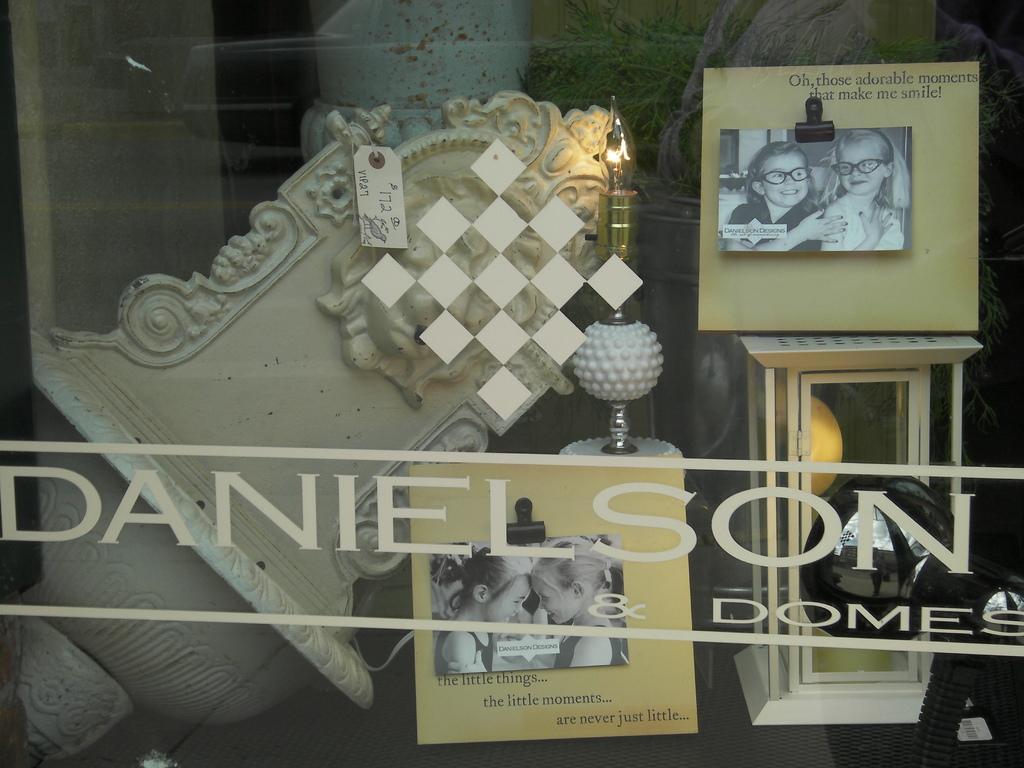In one or two sentences, can you explain what this image depicts? In the foreground of this picture, there are photo frame on a table, a stone structure, a lamp, another frame are present behind the glass and also a text written on it as ¨Daniel son¨. 